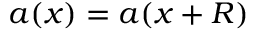Convert formula to latex. <formula><loc_0><loc_0><loc_500><loc_500>\boldsymbol a ( \boldsymbol x ) = \boldsymbol a ( \boldsymbol x + \boldsymbol R )</formula> 